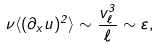<formula> <loc_0><loc_0><loc_500><loc_500>\nu \langle ( \partial _ { x } u ) ^ { 2 } \rangle \sim \frac { v _ { \ell } ^ { 3 } } { \ell } \sim \varepsilon ,</formula> 